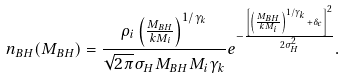Convert formula to latex. <formula><loc_0><loc_0><loc_500><loc_500>n _ { B H } ( M _ { B H } ) = \frac { \rho _ { i } \left ( \frac { M _ { B H } } { k M _ { i } } \right ) ^ { 1 / { \gamma _ { k } } } } { \sqrt { 2 \pi } \sigma _ { H } M _ { B H } M _ { i } \gamma _ { k } } e ^ { - \frac { \left [ \left ( \frac { M _ { B H } } { k M _ { i } } \right ) ^ { 1 / { \gamma _ { k } } } + \delta _ { c } \right ] ^ { 2 } } { 2 \sigma _ { H } ^ { 2 } } } .</formula> 